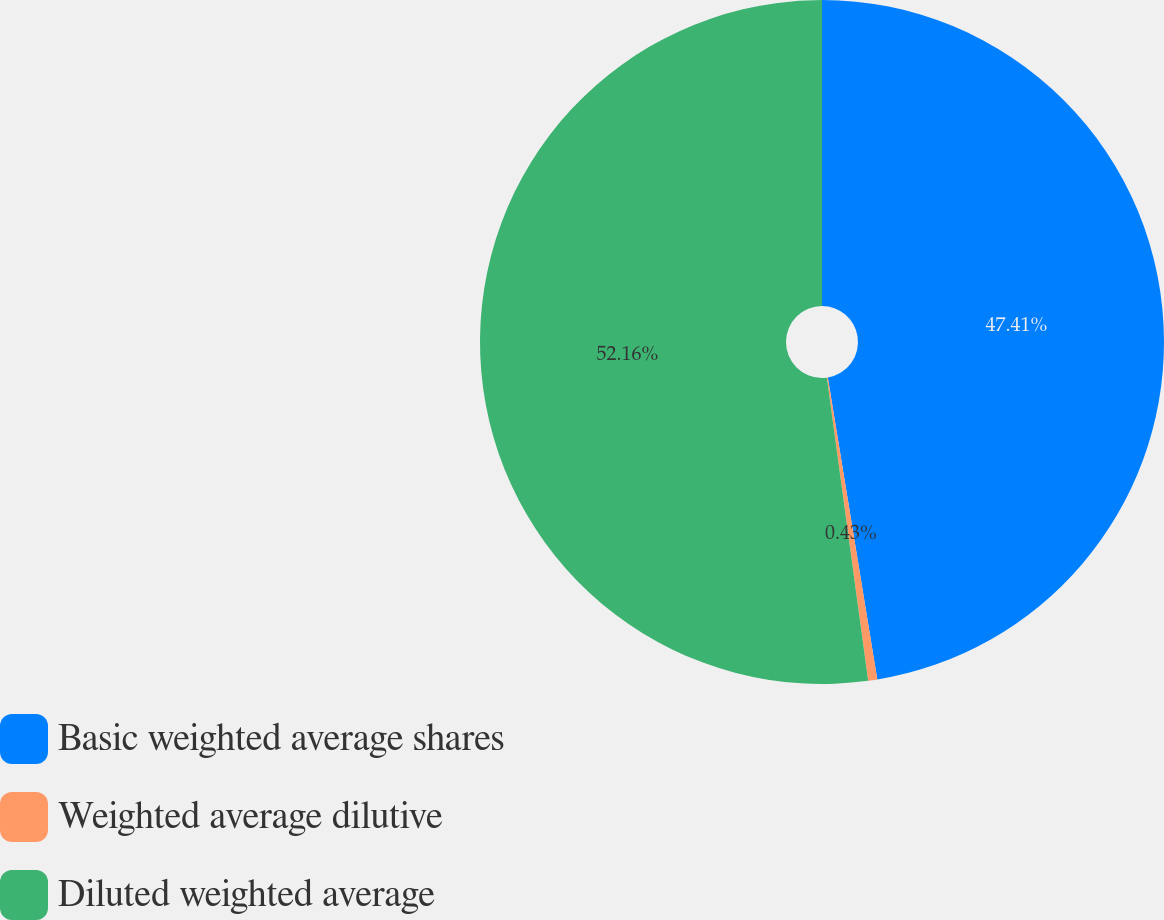<chart> <loc_0><loc_0><loc_500><loc_500><pie_chart><fcel>Basic weighted average shares<fcel>Weighted average dilutive<fcel>Diluted weighted average<nl><fcel>47.41%<fcel>0.43%<fcel>52.15%<nl></chart> 